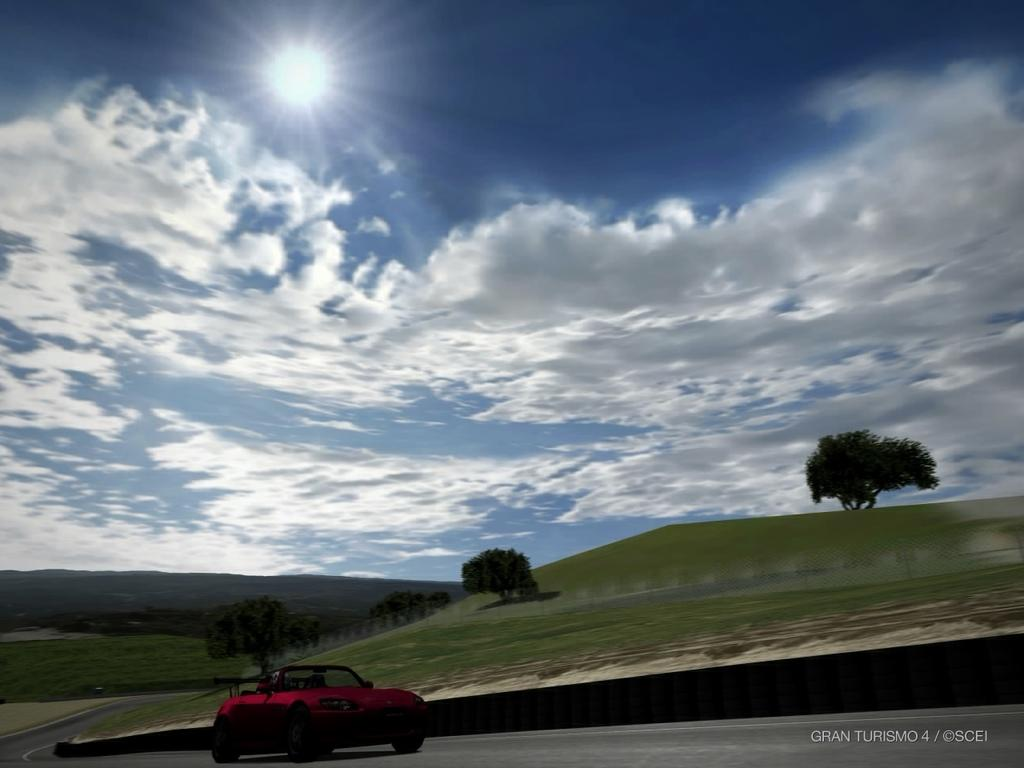What is parked on the road in the image? There is a car parked on the road in the image. What can be seen in the background of the image? There is a group of trees and mountains visible in the background. What is the condition of the sky in the image? The sun is observable in the sky. What is written or displayed at the bottom of the image? There is some text at the bottom of the image. What type of sponge is being used to clean the car in the image? There is no sponge or cleaning activity depicted in the image; it simply shows a parked car. Can you see a church in the background of the image? There is no church visible in the background of the image; it features a group of trees and mountains. 